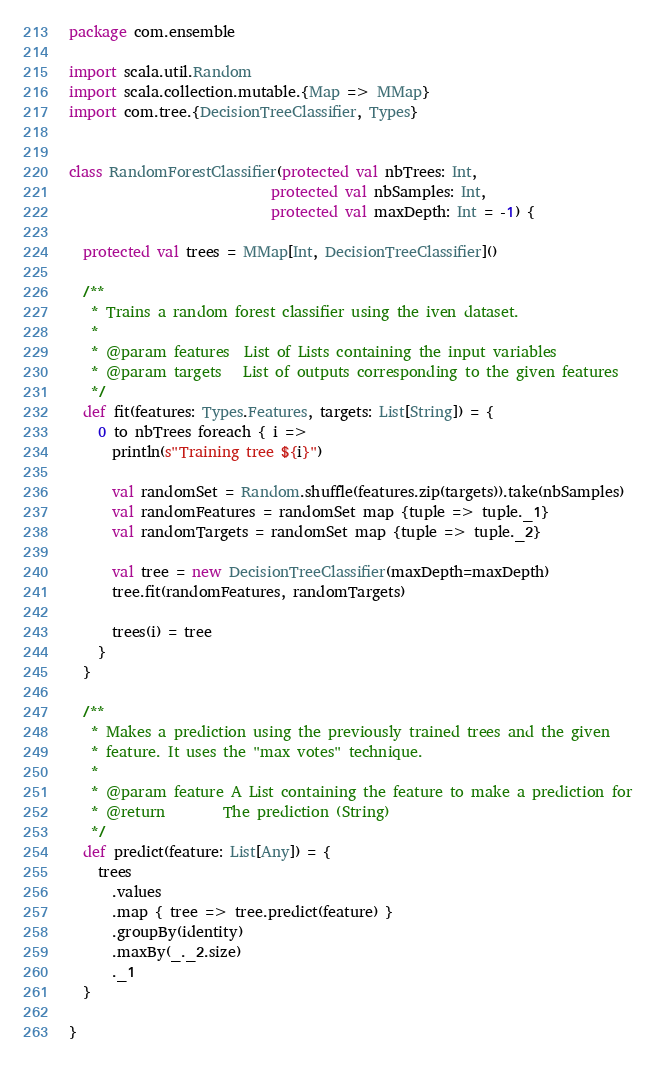<code> <loc_0><loc_0><loc_500><loc_500><_Scala_>package com.ensemble

import scala.util.Random
import scala.collection.mutable.{Map => MMap}
import com.tree.{DecisionTreeClassifier, Types}


class RandomForestClassifier(protected val nbTrees: Int,
                            protected val nbSamples: Int,
                            protected val maxDepth: Int = -1) {

  protected val trees = MMap[Int, DecisionTreeClassifier]()

  /**
   * Trains a random forest classifier using the iven dataset.
   *
   * @param features  List of Lists containing the input variables
   * @param targets   List of outputs corresponding to the given features
   */
  def fit(features: Types.Features, targets: List[String]) = {
    0 to nbTrees foreach { i =>
      println(s"Training tree ${i}")

      val randomSet = Random.shuffle(features.zip(targets)).take(nbSamples)
      val randomFeatures = randomSet map {tuple => tuple._1}
      val randomTargets = randomSet map {tuple => tuple._2}

      val tree = new DecisionTreeClassifier(maxDepth=maxDepth)
      tree.fit(randomFeatures, randomTargets)

      trees(i) = tree
    }
  }

  /**
   * Makes a prediction using the previously trained trees and the given
   * feature. It uses the "max votes" technique.
   *
   * @param feature A List containing the feature to make a prediction for
   * @return        The prediction (String)
   */
  def predict(feature: List[Any]) = {
    trees
      .values
      .map { tree => tree.predict(feature) }
      .groupBy(identity)
      .maxBy(_._2.size)
      ._1
  }

}
</code> 